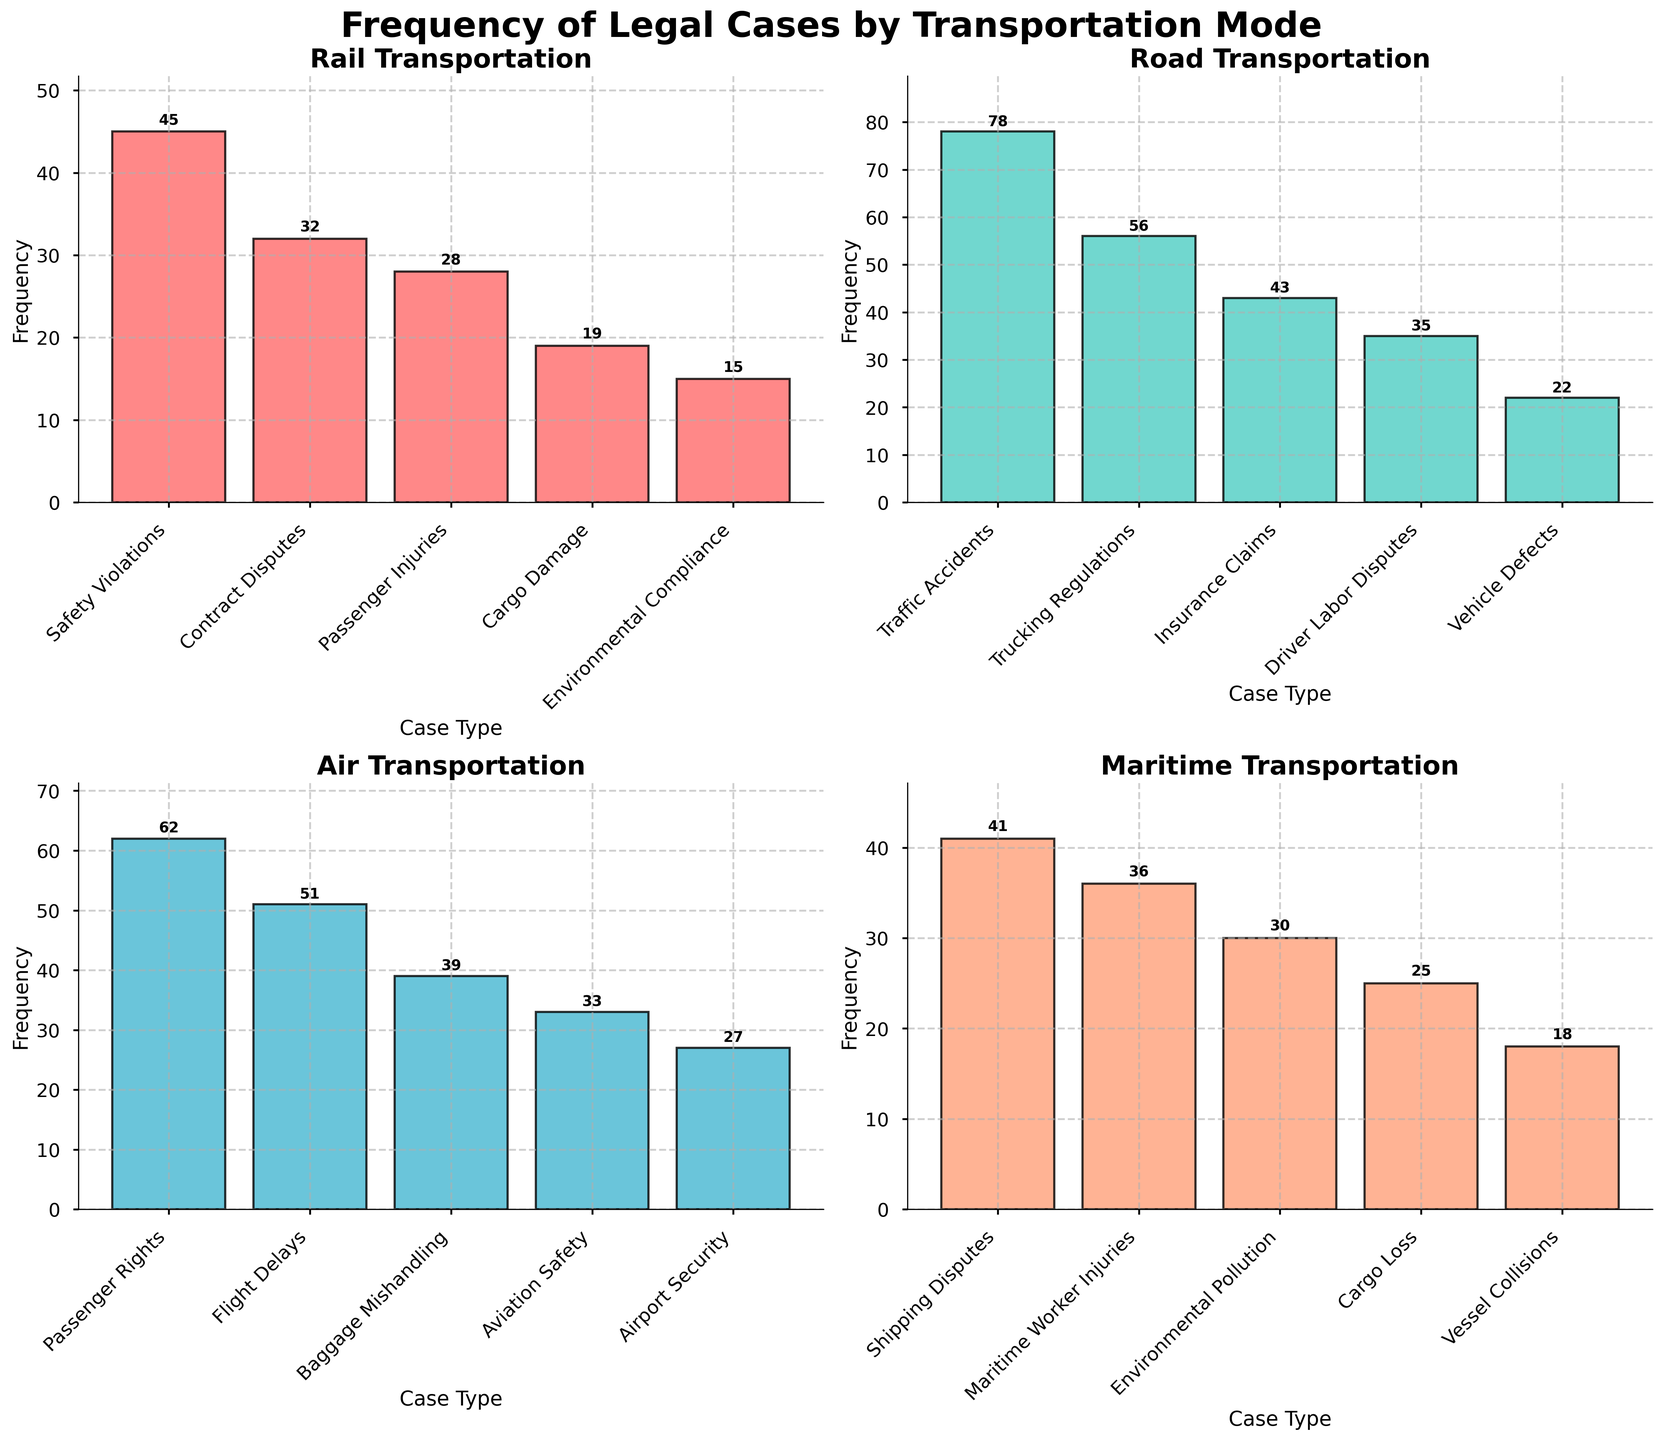What is the title of the figure? The title is located at the top-center of the figure in large and bold font. It clearly states what the figure is about.
Answer: Frequency of Legal Cases by Transportation Mode How many case types are displayed for road transportation? Look at the subplot labeled "Road Transportation" and count the number of distinct bars, each representing a different case type.
Answer: 5 Which transportation mode has the highest frequency of legal cases for any single case type? Examine the highest bar across all subplots. The "Traffic Accidents" case type in the "Road Transportation" subplot has the highest frequency.
Answer: Road What is the combined frequency of environmental-related legal cases for maritime and rail transportation? Identify the bars for "Environmental Pollution" under Maritime and "Environmental Compliance" under Rail. Sum their frequencies: 30 (Maritime) + 15 (Rail) = 45.
Answer: 45 What is the difference in frequency between the highest and lowest case types within air transportation? Find the highest and lowest bars within the "Air Transportation" subplot. The highest is "Passenger Rights" (62) and the lowest is "Airport Security" (27). Their difference is 62 - 27.
Answer: 35 Which case type has the lowest frequency in the maritime transportation subplot? In the "Maritime Transportation" subplot, identify the shortest bar. This represents the "Vessel Collisions" case type.
Answer: Vessel Collisions Is the frequency of "Baggage Mishandling" in air transportation higher than "Cargo Damage" in rail transportation? Compare the height of the "Baggage Mishandling" bar in the air subplot (39) to the "Cargo Damage" bar in the rail subplot (19).
Answer: Yes Calculate the average frequency of case types in road transportation. Sum all the frequencies for road cases and divide by the number of case types. (78 + 56 + 43 + 35 + 22) / 5 = 46.8.
Answer: 46.8 